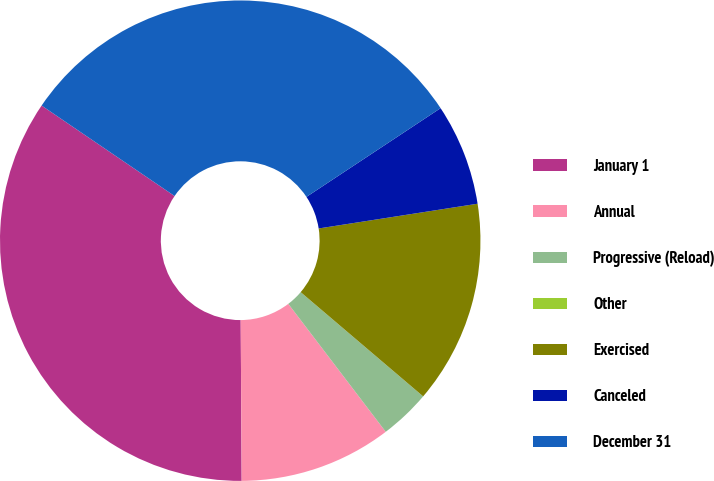Convert chart to OTSL. <chart><loc_0><loc_0><loc_500><loc_500><pie_chart><fcel>January 1<fcel>Annual<fcel>Progressive (Reload)<fcel>Other<fcel>Exercised<fcel>Canceled<fcel>December 31<nl><fcel>34.6%<fcel>10.26%<fcel>3.42%<fcel>0.0%<fcel>13.68%<fcel>6.84%<fcel>31.19%<nl></chart> 